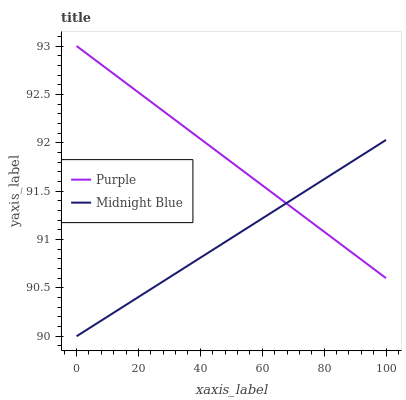Does Midnight Blue have the minimum area under the curve?
Answer yes or no. Yes. Does Purple have the maximum area under the curve?
Answer yes or no. Yes. Does Midnight Blue have the maximum area under the curve?
Answer yes or no. No. Is Purple the smoothest?
Answer yes or no. Yes. Is Midnight Blue the roughest?
Answer yes or no. Yes. Is Midnight Blue the smoothest?
Answer yes or no. No. Does Midnight Blue have the lowest value?
Answer yes or no. Yes. Does Purple have the highest value?
Answer yes or no. Yes. Does Midnight Blue have the highest value?
Answer yes or no. No. Does Midnight Blue intersect Purple?
Answer yes or no. Yes. Is Midnight Blue less than Purple?
Answer yes or no. No. Is Midnight Blue greater than Purple?
Answer yes or no. No. 